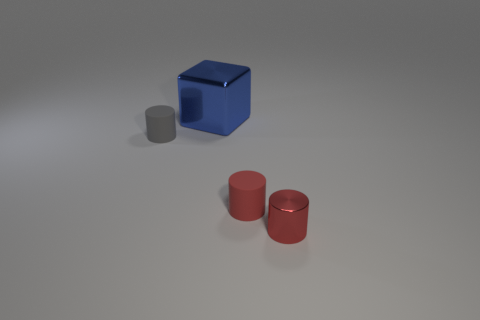There is a tiny red object behind the red object that is on the right side of the tiny red object that is behind the small shiny object; what is its shape?
Your answer should be very brief. Cylinder. Is the tiny cylinder on the left side of the blue metal object made of the same material as the object behind the tiny gray thing?
Offer a terse response. No. The metallic thing that is behind the gray object has what shape?
Provide a short and direct response. Cube. Are there fewer large green matte cylinders than gray things?
Provide a succinct answer. Yes. There is a red cylinder that is in front of the small red object that is behind the red metallic object; is there a tiny gray thing that is on the right side of it?
Offer a terse response. No. How many rubber objects are either red things or tiny things?
Make the answer very short. 2. Do the metal cube and the metal cylinder have the same color?
Your answer should be compact. No. There is a tiny gray cylinder; how many gray rubber things are to the left of it?
Your answer should be compact. 0. What number of objects are both in front of the blue block and right of the tiny gray object?
Give a very brief answer. 2. The other red object that is the same material as the large object is what shape?
Provide a succinct answer. Cylinder. 